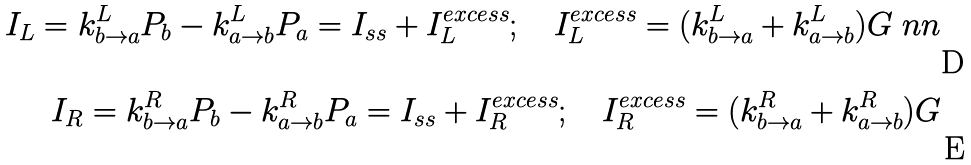<formula> <loc_0><loc_0><loc_500><loc_500>I _ { L } = k ^ { L } _ { b \to a } P _ { b } - k ^ { L } _ { a \to b } P _ { a } = I _ { s s } + I _ { L } ^ { e x c e s s } ; \quad I _ { L } ^ { e x c e s s } = ( k ^ { L } _ { b \to a } + k ^ { L } _ { a \to b } ) G \ n n \\ I _ { R } = k ^ { R } _ { b \to a } P _ { b } - k ^ { R } _ { a \to b } P _ { a } = I _ { s s } + I _ { R } ^ { e x c e s s } ; \quad I _ { R } ^ { e x c e s s } = ( k ^ { R } _ { b \to a } + k ^ { R } _ { a \to b } ) G</formula> 